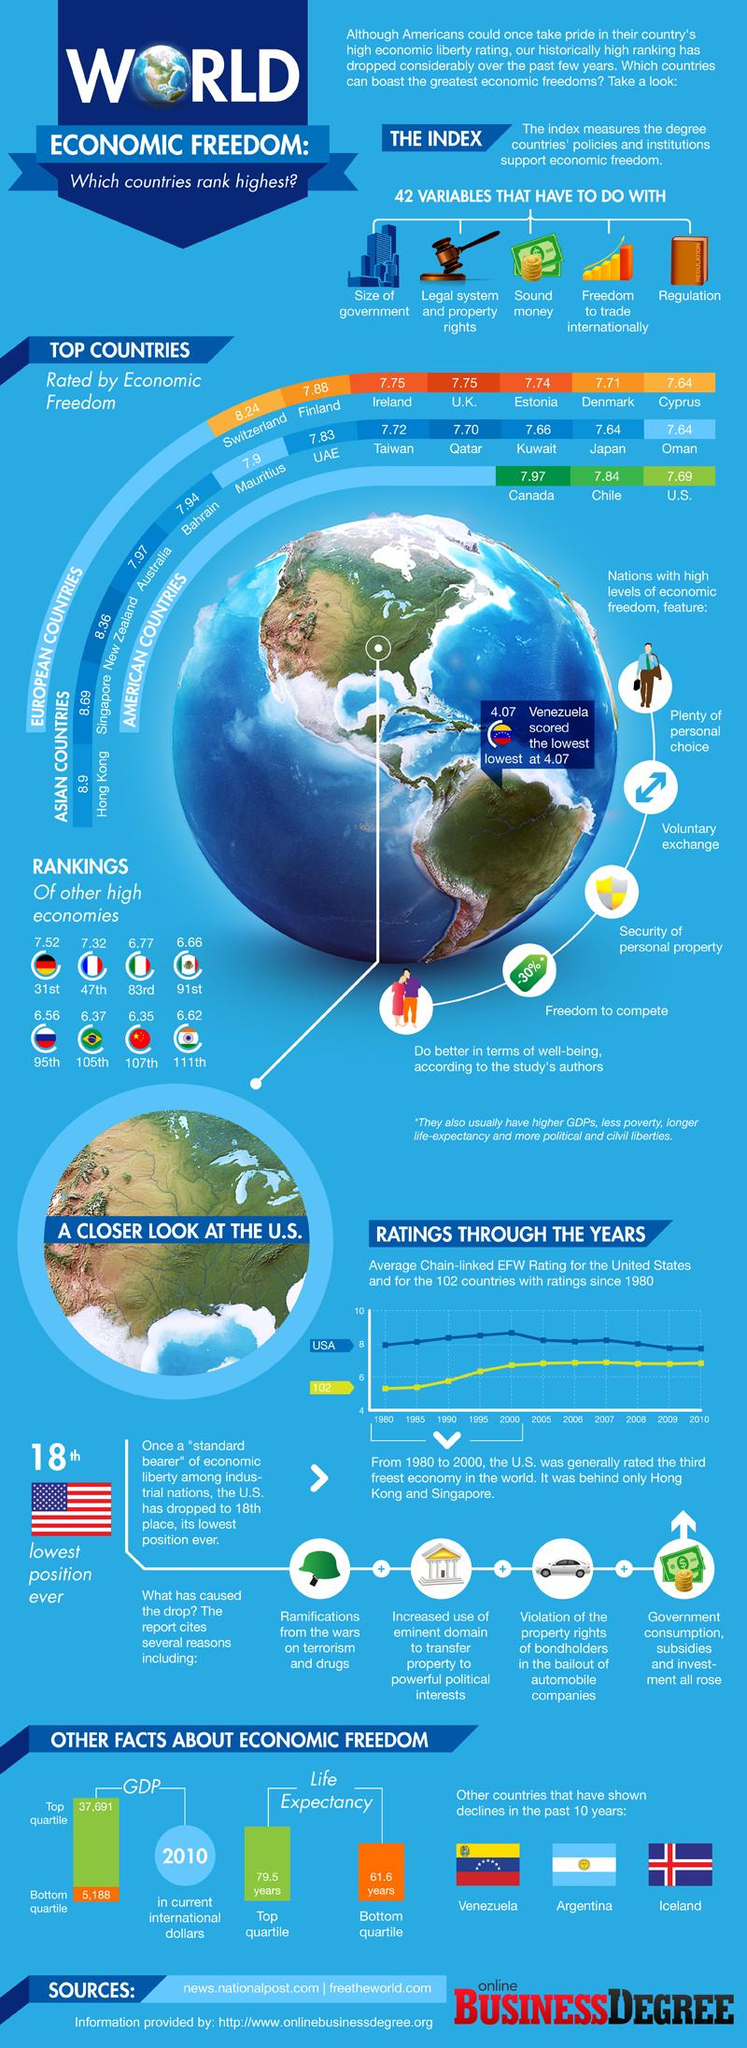Mention a couple of crucial points in this snapshot. Countries with high economic freedom enjoy the advantage of freedom to compete, which is the fourth listed advantage. Chile has the second-highest rate of economic freedom in the United States, according to recent data. Countries with high economic freedom enjoy the advantage of voluntary exchange, which allows individuals and businesses to freely trade goods and services without government intervention. The economic freedom of India is 6.62 out of 10, according to the latest report. According to the Heritage Foundation's Index of Economic Freedom, Denmark has the second-lowest level of economic freedom out of all European countries. 